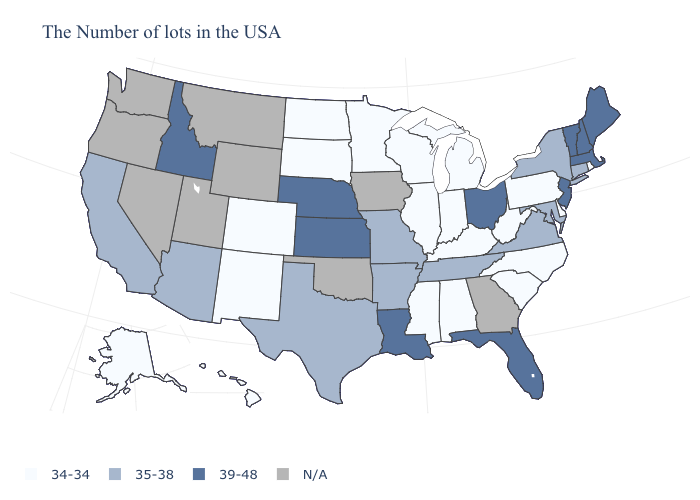Which states hav the highest value in the South?
Answer briefly. Florida, Louisiana. What is the value of Michigan?
Give a very brief answer. 34-34. Does California have the lowest value in the USA?
Concise answer only. No. Which states have the lowest value in the West?
Short answer required. Colorado, New Mexico, Alaska, Hawaii. Name the states that have a value in the range 35-38?
Give a very brief answer. Connecticut, New York, Maryland, Virginia, Tennessee, Missouri, Arkansas, Texas, Arizona, California. What is the value of Washington?
Write a very short answer. N/A. Name the states that have a value in the range 34-34?
Be succinct. Rhode Island, Delaware, Pennsylvania, North Carolina, South Carolina, West Virginia, Michigan, Kentucky, Indiana, Alabama, Wisconsin, Illinois, Mississippi, Minnesota, South Dakota, North Dakota, Colorado, New Mexico, Alaska, Hawaii. What is the highest value in states that border Massachusetts?
Answer briefly. 39-48. Which states hav the highest value in the South?
Answer briefly. Florida, Louisiana. What is the value of Maryland?
Keep it brief. 35-38. Among the states that border Kentucky , does West Virginia have the lowest value?
Concise answer only. Yes. Does Maine have the lowest value in the USA?
Short answer required. No. Does Ohio have the lowest value in the MidWest?
Be succinct. No. 